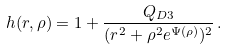<formula> <loc_0><loc_0><loc_500><loc_500>h ( r , \rho ) = 1 + \frac { Q _ { D 3 } } { ( r ^ { 2 } + \rho ^ { 2 } e ^ { \Psi ( \rho ) } ) ^ { 2 } } \, .</formula> 